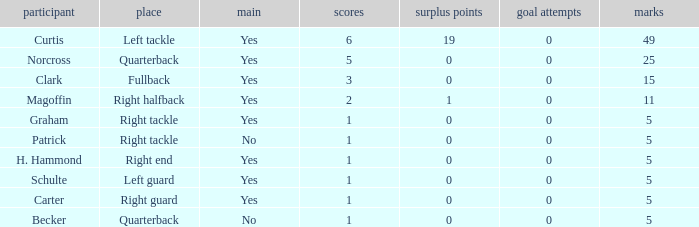Name the most field goals 0.0. 